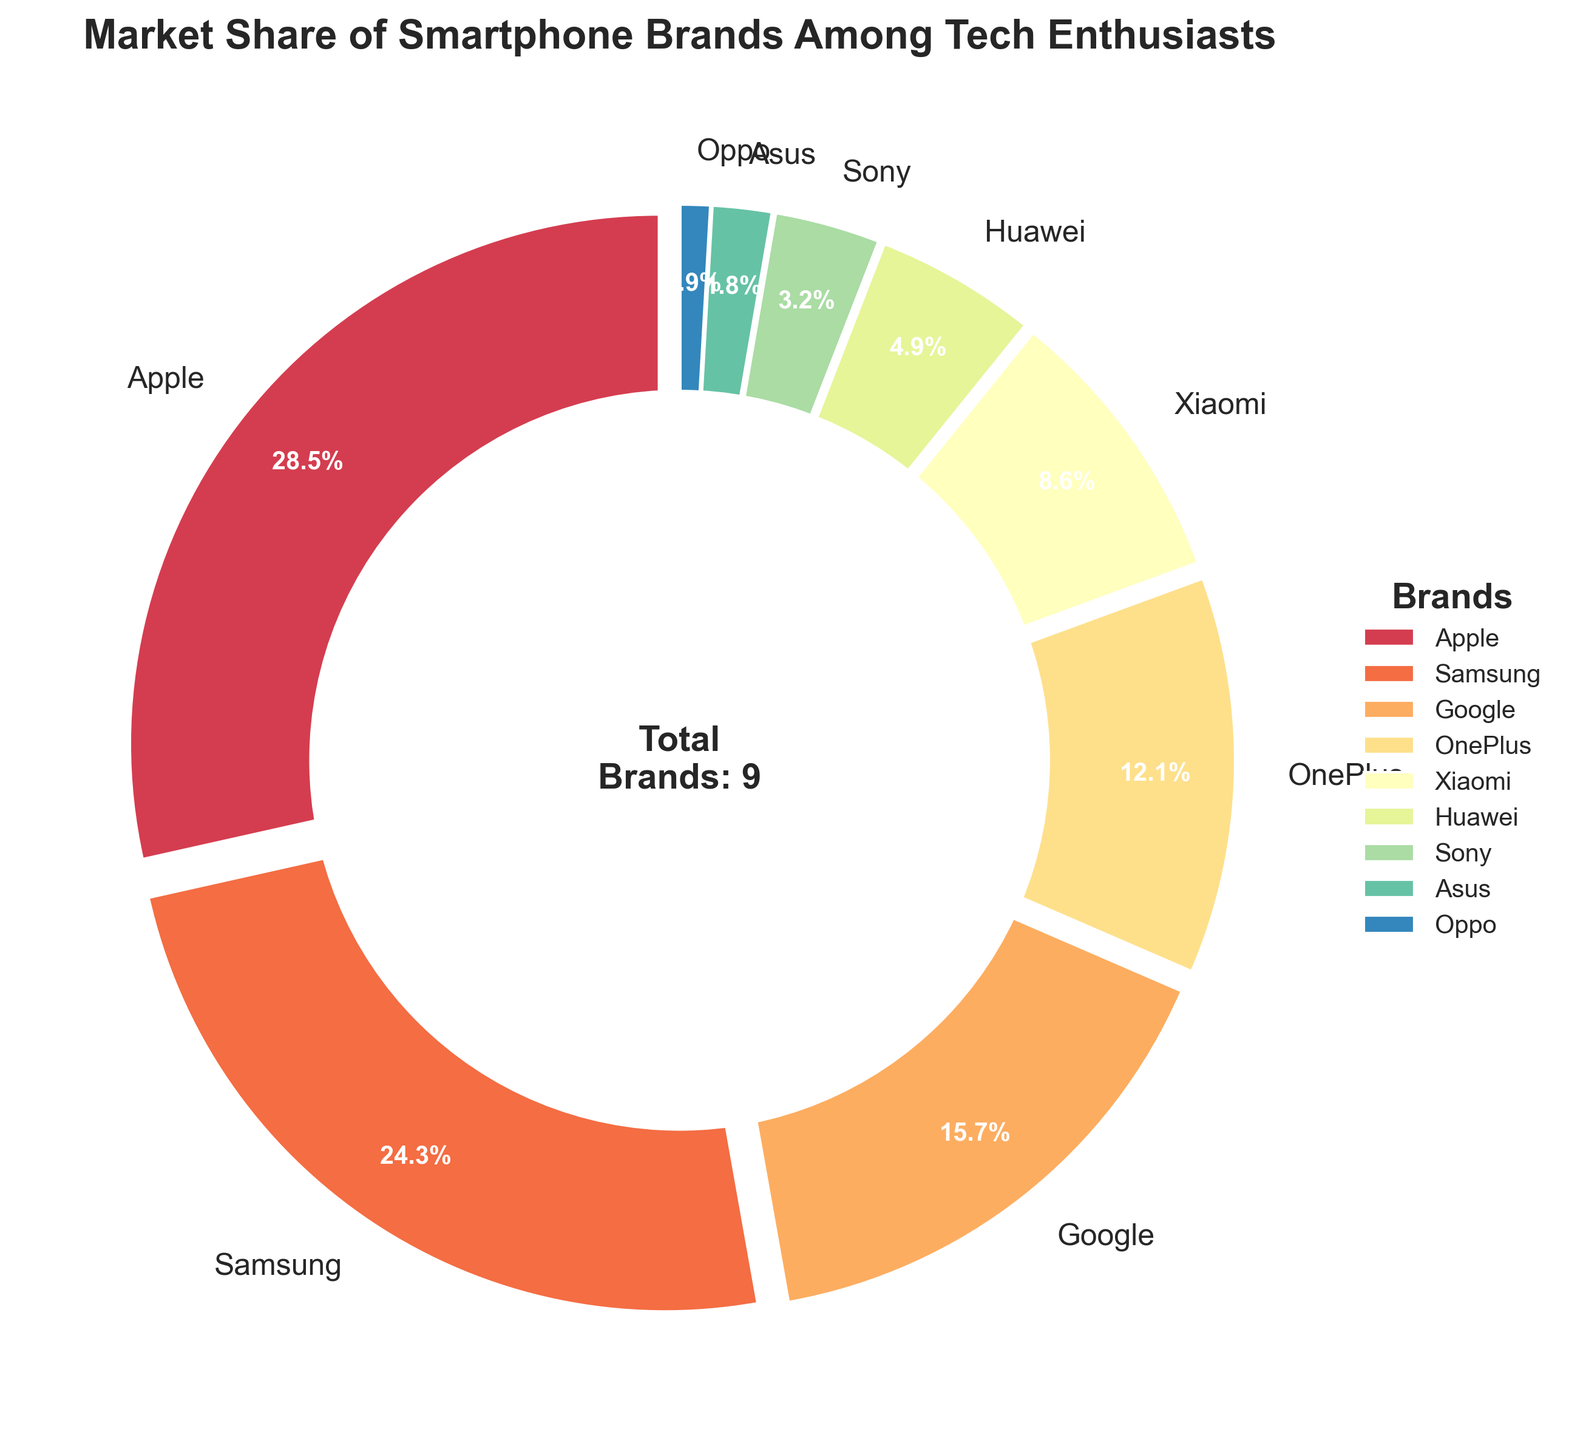Which brand has the highest market share? The pie chart shows that Apple has the largest wedge, indicating the highest percentage.
Answer: Apple Which two brands together have a market share close to 40%? Adding the market shares of Google (15.7%) and OnePlus (12.1%) gives 27.8%, and adding Samsung (24.3%) and Xiaomi (8.6%) gives 32.9%. Adding Samsung (24.3%) and OnePlus (12.1%) gives 36.4%, which is closer.
Answer: Samsung and OnePlus Which brand has the smallest market share, and how much is it? The pie chart shows the smallest wedge is for Oppo, and its market share label shows 0.9%.
Answer: Oppo, 0.9% What is the difference in market share between Apple and Samsung? Apple has a market share of 28.5%, and Samsung has 24.3%. Subtracting Samsung's share from Apple's gives 28.5% - 24.3% = 4.2%.
Answer: 4.2% What is the combined market share of brands with less than 10% market share each? Summing the market shares for Xiaomi (8.6%), Huawei (4.9%), Sony (3.2%), Asus (1.8%), and Oppo (0.9%) gives 8.6% + 4.9% + 3.2% + 1.8% + 0.9% = 19.4%.
Answer: 19.4% Which brands have a market share greater than 15%? The pie chart shows that Apple (28.5%), Samsung (24.3%), and Google (15.7%) have wedges larger than the others, indicating market shares over 15%.
Answer: Apple, Samsung, Google If a new brand enters the market and takes 5% of the share from existing brands proportionally, what would be Samsung's new market share? Samsung's current market share is 24.3%. After redistributing 5% proportionally from all brands, reduction in Samsung's share is 24.3% * (5%/100%) = 1.22%. New share is 24.3% - 1.22% = 23.08%.
Answer: 23.08% How much larger is OnePlus's market share compared to Sony's? OnePlus has a market share of 12.1%, and Sony has 3.2%. Subtracting Sony's share from OnePlus's gives 12.1% - 3.2% = 8.9%.
Answer: 8.9% What percentage of the market is dominated by the top two brands combined? The top two brands by market share are Apple (28.5%) and Samsung (24.3%). Their combined market share is 28.5% + 24.3% = 52.8%.
Answer: 52.8% 